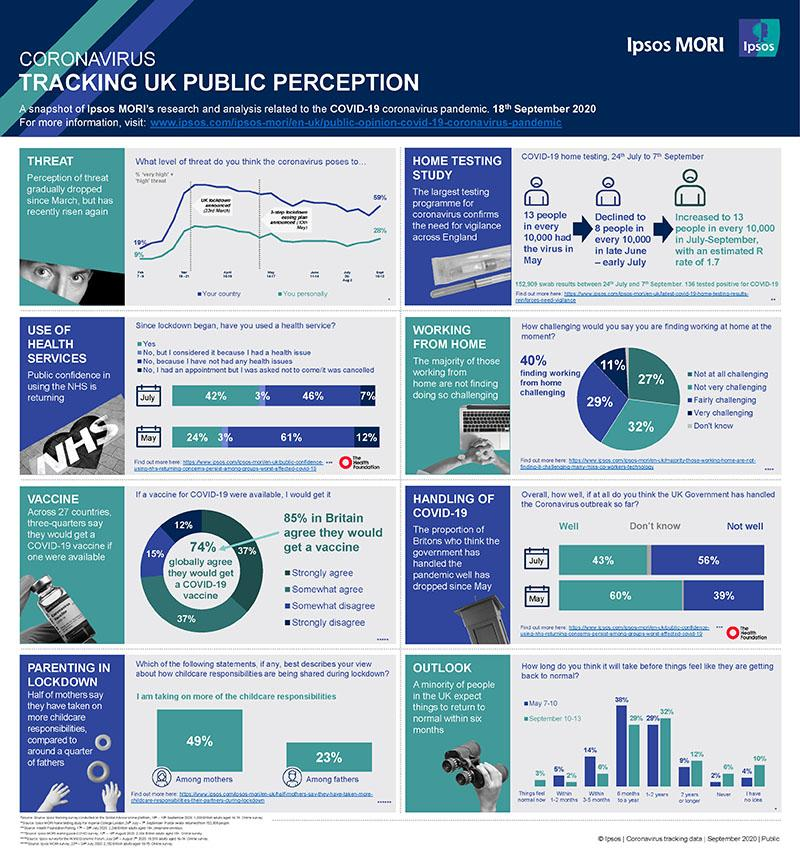Mention a couple of crucial points in this snapshot. In July, 46% of people in the UK did not use health services due to the lack of health issues they were experiencing. According to a recent global survey, a significant percentage of people worldwide disagree with the use of vaccinations. According to the survey, 59% of people who find it challenging to work from home feel the same way. According to a recent survey, 40% of people find it challenging to work from home. In July, 42% of the people in the United Kingdom used health services. 